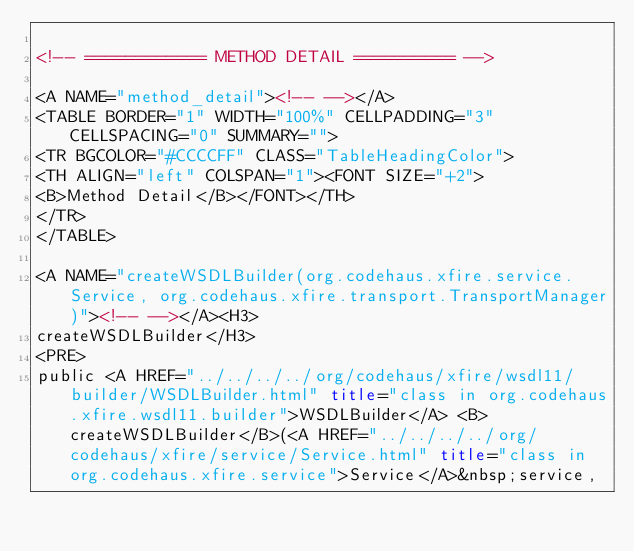Convert code to text. <code><loc_0><loc_0><loc_500><loc_500><_HTML_>
<!-- ============ METHOD DETAIL ========== -->

<A NAME="method_detail"><!-- --></A>
<TABLE BORDER="1" WIDTH="100%" CELLPADDING="3" CELLSPACING="0" SUMMARY="">
<TR BGCOLOR="#CCCCFF" CLASS="TableHeadingColor">
<TH ALIGN="left" COLSPAN="1"><FONT SIZE="+2">
<B>Method Detail</B></FONT></TH>
</TR>
</TABLE>

<A NAME="createWSDLBuilder(org.codehaus.xfire.service.Service, org.codehaus.xfire.transport.TransportManager)"><!-- --></A><H3>
createWSDLBuilder</H3>
<PRE>
public <A HREF="../../../../org/codehaus/xfire/wsdl11/builder/WSDLBuilder.html" title="class in org.codehaus.xfire.wsdl11.builder">WSDLBuilder</A> <B>createWSDLBuilder</B>(<A HREF="../../../../org/codehaus/xfire/service/Service.html" title="class in org.codehaus.xfire.service">Service</A>&nbsp;service,</code> 